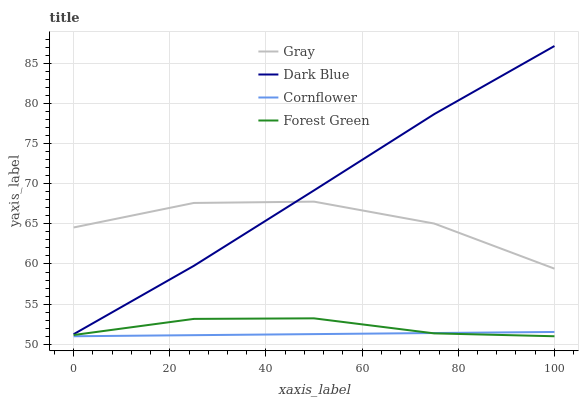Does Cornflower have the minimum area under the curve?
Answer yes or no. Yes. Does Dark Blue have the maximum area under the curve?
Answer yes or no. Yes. Does Forest Green have the minimum area under the curve?
Answer yes or no. No. Does Forest Green have the maximum area under the curve?
Answer yes or no. No. Is Cornflower the smoothest?
Answer yes or no. Yes. Is Gray the roughest?
Answer yes or no. Yes. Is Forest Green the smoothest?
Answer yes or no. No. Is Forest Green the roughest?
Answer yes or no. No. Does Forest Green have the lowest value?
Answer yes or no. Yes. Does Dark Blue have the lowest value?
Answer yes or no. No. Does Dark Blue have the highest value?
Answer yes or no. Yes. Does Forest Green have the highest value?
Answer yes or no. No. Is Forest Green less than Gray?
Answer yes or no. Yes. Is Gray greater than Forest Green?
Answer yes or no. Yes. Does Gray intersect Dark Blue?
Answer yes or no. Yes. Is Gray less than Dark Blue?
Answer yes or no. No. Is Gray greater than Dark Blue?
Answer yes or no. No. Does Forest Green intersect Gray?
Answer yes or no. No. 